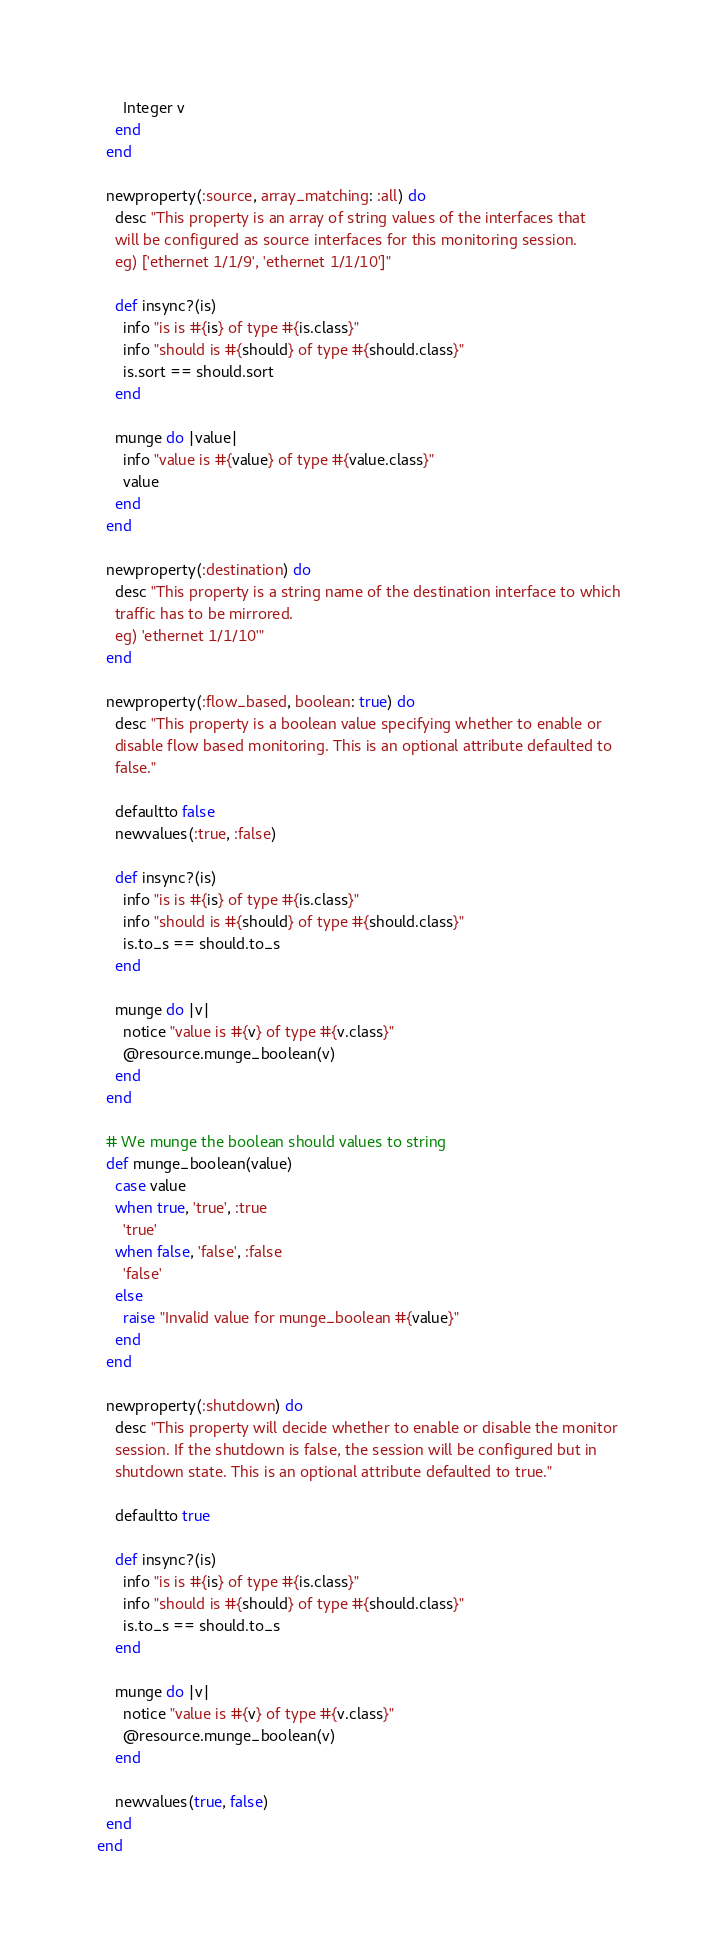Convert code to text. <code><loc_0><loc_0><loc_500><loc_500><_Ruby_>      Integer v
    end
  end

  newproperty(:source, array_matching: :all) do
    desc "This property is an array of string values of the interfaces that
    will be configured as source interfaces for this monitoring session.
    eg) ['ethernet 1/1/9', 'ethernet 1/1/10']"

    def insync?(is)
      info "is is #{is} of type #{is.class}"
      info "should is #{should} of type #{should.class}"
      is.sort == should.sort
    end

    munge do |value|
      info "value is #{value} of type #{value.class}"
      value
    end
  end

  newproperty(:destination) do
    desc "This property is a string name of the destination interface to which
    traffic has to be mirrored.
    eg) 'ethernet 1/1/10'"
  end

  newproperty(:flow_based, boolean: true) do
    desc "This property is a boolean value specifying whether to enable or
    disable flow based monitoring. This is an optional attribute defaulted to
    false."

    defaultto false
    newvalues(:true, :false)

    def insync?(is)
      info "is is #{is} of type #{is.class}"
      info "should is #{should} of type #{should.class}"
      is.to_s == should.to_s
    end

    munge do |v|
      notice "value is #{v} of type #{v.class}"
      @resource.munge_boolean(v)
    end
  end

  # We munge the boolean should values to string
  def munge_boolean(value)
    case value
    when true, 'true', :true
      'true'
    when false, 'false', :false
      'false'
    else
      raise "Invalid value for munge_boolean #{value}"
    end
  end

  newproperty(:shutdown) do
    desc "This property will decide whether to enable or disable the monitor
    session. If the shutdown is false, the session will be configured but in
    shutdown state. This is an optional attribute defaulted to true."

    defaultto true

    def insync?(is)
      info "is is #{is} of type #{is.class}"
      info "should is #{should} of type #{should.class}"
      is.to_s == should.to_s
    end

    munge do |v|
      notice "value is #{v} of type #{v.class}"
      @resource.munge_boolean(v)
    end

    newvalues(true, false)
  end
end
</code> 